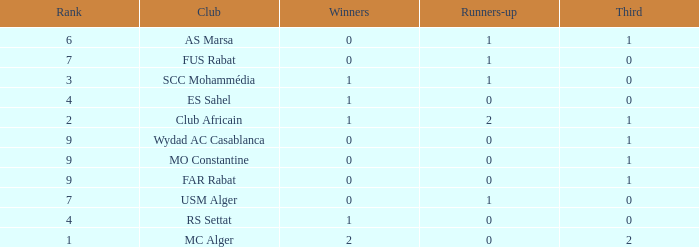Which Winners is the highest one that has a Rank larger than 7, and a Third smaller than 1? None. 